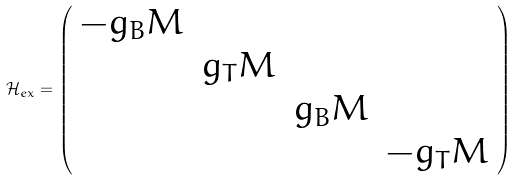Convert formula to latex. <formula><loc_0><loc_0><loc_500><loc_500>\mathcal { H } _ { e x } = \left ( \begin{array} { c c c c } - g _ { B } M & & & \\ & g _ { T } M & & \\ & & g _ { B } M & \\ & & & - g _ { T } M \end{array} \right )</formula> 